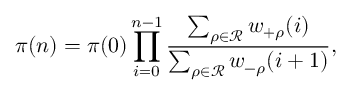<formula> <loc_0><loc_0><loc_500><loc_500>\pi ( n ) = \pi ( 0 ) \prod _ { i = 0 } ^ { n - 1 } \frac { \sum _ { \rho \in \mathcal { R } } w _ { + \rho } ( i ) } { \sum _ { \rho \in \mathcal { R } } w _ { - \rho } ( i + 1 ) } ,</formula> 